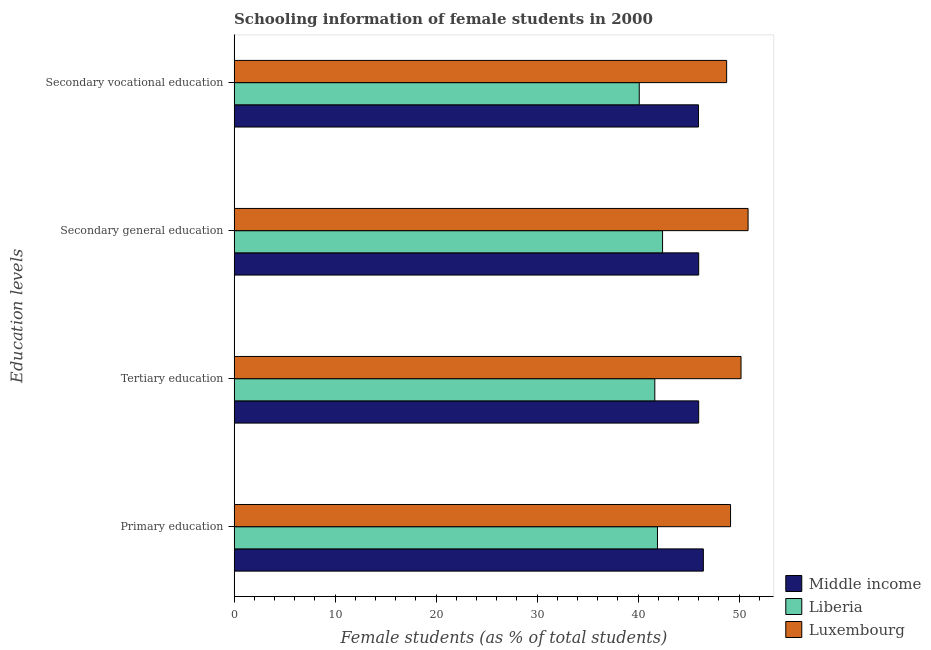How many different coloured bars are there?
Ensure brevity in your answer.  3. How many groups of bars are there?
Keep it short and to the point. 4. Are the number of bars per tick equal to the number of legend labels?
Provide a succinct answer. Yes. Are the number of bars on each tick of the Y-axis equal?
Give a very brief answer. Yes. How many bars are there on the 4th tick from the top?
Make the answer very short. 3. What is the label of the 2nd group of bars from the top?
Offer a very short reply. Secondary general education. What is the percentage of female students in tertiary education in Middle income?
Offer a very short reply. 46. Across all countries, what is the maximum percentage of female students in primary education?
Your answer should be compact. 49.16. Across all countries, what is the minimum percentage of female students in secondary vocational education?
Ensure brevity in your answer.  40.12. In which country was the percentage of female students in primary education maximum?
Provide a short and direct response. Luxembourg. In which country was the percentage of female students in primary education minimum?
Your response must be concise. Liberia. What is the total percentage of female students in primary education in the graph?
Your response must be concise. 137.54. What is the difference between the percentage of female students in secondary vocational education in Luxembourg and that in Middle income?
Give a very brief answer. 2.79. What is the difference between the percentage of female students in primary education in Middle income and the percentage of female students in secondary education in Luxembourg?
Your response must be concise. -4.43. What is the average percentage of female students in primary education per country?
Your answer should be compact. 45.85. What is the difference between the percentage of female students in secondary education and percentage of female students in secondary vocational education in Middle income?
Keep it short and to the point. 0.02. In how many countries, is the percentage of female students in secondary education greater than 38 %?
Make the answer very short. 3. What is the ratio of the percentage of female students in secondary vocational education in Middle income to that in Luxembourg?
Your response must be concise. 0.94. Is the percentage of female students in tertiary education in Middle income less than that in Luxembourg?
Keep it short and to the point. Yes. What is the difference between the highest and the second highest percentage of female students in secondary vocational education?
Ensure brevity in your answer.  2.79. What is the difference between the highest and the lowest percentage of female students in secondary education?
Keep it short and to the point. 8.47. Is the sum of the percentage of female students in tertiary education in Liberia and Luxembourg greater than the maximum percentage of female students in secondary vocational education across all countries?
Your answer should be compact. Yes. Is it the case that in every country, the sum of the percentage of female students in tertiary education and percentage of female students in primary education is greater than the sum of percentage of female students in secondary vocational education and percentage of female students in secondary education?
Your answer should be compact. No. What does the 1st bar from the top in Secondary general education represents?
Offer a terse response. Luxembourg. What does the 3rd bar from the bottom in Secondary vocational education represents?
Offer a very short reply. Luxembourg. Does the graph contain grids?
Your answer should be very brief. No. Where does the legend appear in the graph?
Keep it short and to the point. Bottom right. How are the legend labels stacked?
Keep it short and to the point. Vertical. What is the title of the graph?
Your answer should be very brief. Schooling information of female students in 2000. Does "Seychelles" appear as one of the legend labels in the graph?
Your answer should be compact. No. What is the label or title of the X-axis?
Offer a terse response. Female students (as % of total students). What is the label or title of the Y-axis?
Make the answer very short. Education levels. What is the Female students (as % of total students) of Middle income in Primary education?
Your answer should be compact. 46.46. What is the Female students (as % of total students) of Liberia in Primary education?
Offer a terse response. 41.92. What is the Female students (as % of total students) in Luxembourg in Primary education?
Give a very brief answer. 49.16. What is the Female students (as % of total students) in Middle income in Tertiary education?
Make the answer very short. 46. What is the Female students (as % of total students) of Liberia in Tertiary education?
Make the answer very short. 41.66. What is the Female students (as % of total students) in Luxembourg in Tertiary education?
Your answer should be compact. 50.19. What is the Female students (as % of total students) of Middle income in Secondary general education?
Offer a very short reply. 46. What is the Female students (as % of total students) of Liberia in Secondary general education?
Offer a very short reply. 42.42. What is the Female students (as % of total students) in Luxembourg in Secondary general education?
Ensure brevity in your answer.  50.89. What is the Female students (as % of total students) in Middle income in Secondary vocational education?
Give a very brief answer. 45.98. What is the Female students (as % of total students) in Liberia in Secondary vocational education?
Offer a terse response. 40.12. What is the Female students (as % of total students) in Luxembourg in Secondary vocational education?
Provide a short and direct response. 48.77. Across all Education levels, what is the maximum Female students (as % of total students) of Middle income?
Offer a very short reply. 46.46. Across all Education levels, what is the maximum Female students (as % of total students) of Liberia?
Keep it short and to the point. 42.42. Across all Education levels, what is the maximum Female students (as % of total students) of Luxembourg?
Provide a succinct answer. 50.89. Across all Education levels, what is the minimum Female students (as % of total students) of Middle income?
Offer a terse response. 45.98. Across all Education levels, what is the minimum Female students (as % of total students) in Liberia?
Provide a short and direct response. 40.12. Across all Education levels, what is the minimum Female students (as % of total students) of Luxembourg?
Your answer should be compact. 48.77. What is the total Female students (as % of total students) of Middle income in the graph?
Ensure brevity in your answer.  184.45. What is the total Female students (as % of total students) of Liberia in the graph?
Ensure brevity in your answer.  166.12. What is the total Female students (as % of total students) in Luxembourg in the graph?
Make the answer very short. 199.01. What is the difference between the Female students (as % of total students) in Middle income in Primary education and that in Tertiary education?
Provide a short and direct response. 0.47. What is the difference between the Female students (as % of total students) in Liberia in Primary education and that in Tertiary education?
Provide a succinct answer. 0.26. What is the difference between the Female students (as % of total students) of Luxembourg in Primary education and that in Tertiary education?
Keep it short and to the point. -1.04. What is the difference between the Female students (as % of total students) in Middle income in Primary education and that in Secondary general education?
Your response must be concise. 0.46. What is the difference between the Female students (as % of total students) in Liberia in Primary education and that in Secondary general education?
Provide a succinct answer. -0.51. What is the difference between the Female students (as % of total students) in Luxembourg in Primary education and that in Secondary general education?
Keep it short and to the point. -1.74. What is the difference between the Female students (as % of total students) of Middle income in Primary education and that in Secondary vocational education?
Your answer should be very brief. 0.49. What is the difference between the Female students (as % of total students) in Liberia in Primary education and that in Secondary vocational education?
Your answer should be compact. 1.8. What is the difference between the Female students (as % of total students) in Luxembourg in Primary education and that in Secondary vocational education?
Keep it short and to the point. 0.39. What is the difference between the Female students (as % of total students) of Middle income in Tertiary education and that in Secondary general education?
Keep it short and to the point. -0. What is the difference between the Female students (as % of total students) in Liberia in Tertiary education and that in Secondary general education?
Your answer should be very brief. -0.77. What is the difference between the Female students (as % of total students) in Luxembourg in Tertiary education and that in Secondary general education?
Your response must be concise. -0.7. What is the difference between the Female students (as % of total students) in Middle income in Tertiary education and that in Secondary vocational education?
Your response must be concise. 0.02. What is the difference between the Female students (as % of total students) of Liberia in Tertiary education and that in Secondary vocational education?
Ensure brevity in your answer.  1.54. What is the difference between the Female students (as % of total students) in Luxembourg in Tertiary education and that in Secondary vocational education?
Make the answer very short. 1.42. What is the difference between the Female students (as % of total students) of Middle income in Secondary general education and that in Secondary vocational education?
Keep it short and to the point. 0.02. What is the difference between the Female students (as % of total students) of Liberia in Secondary general education and that in Secondary vocational education?
Your answer should be compact. 2.31. What is the difference between the Female students (as % of total students) in Luxembourg in Secondary general education and that in Secondary vocational education?
Ensure brevity in your answer.  2.12. What is the difference between the Female students (as % of total students) in Middle income in Primary education and the Female students (as % of total students) in Liberia in Tertiary education?
Provide a succinct answer. 4.81. What is the difference between the Female students (as % of total students) in Middle income in Primary education and the Female students (as % of total students) in Luxembourg in Tertiary education?
Make the answer very short. -3.73. What is the difference between the Female students (as % of total students) in Liberia in Primary education and the Female students (as % of total students) in Luxembourg in Tertiary education?
Offer a terse response. -8.27. What is the difference between the Female students (as % of total students) of Middle income in Primary education and the Female students (as % of total students) of Liberia in Secondary general education?
Give a very brief answer. 4.04. What is the difference between the Female students (as % of total students) in Middle income in Primary education and the Female students (as % of total students) in Luxembourg in Secondary general education?
Keep it short and to the point. -4.43. What is the difference between the Female students (as % of total students) in Liberia in Primary education and the Female students (as % of total students) in Luxembourg in Secondary general education?
Give a very brief answer. -8.97. What is the difference between the Female students (as % of total students) of Middle income in Primary education and the Female students (as % of total students) of Liberia in Secondary vocational education?
Ensure brevity in your answer.  6.35. What is the difference between the Female students (as % of total students) of Middle income in Primary education and the Female students (as % of total students) of Luxembourg in Secondary vocational education?
Keep it short and to the point. -2.31. What is the difference between the Female students (as % of total students) of Liberia in Primary education and the Female students (as % of total students) of Luxembourg in Secondary vocational education?
Provide a succinct answer. -6.85. What is the difference between the Female students (as % of total students) in Middle income in Tertiary education and the Female students (as % of total students) in Liberia in Secondary general education?
Your answer should be compact. 3.57. What is the difference between the Female students (as % of total students) in Middle income in Tertiary education and the Female students (as % of total students) in Luxembourg in Secondary general education?
Keep it short and to the point. -4.89. What is the difference between the Female students (as % of total students) in Liberia in Tertiary education and the Female students (as % of total students) in Luxembourg in Secondary general education?
Your response must be concise. -9.23. What is the difference between the Female students (as % of total students) of Middle income in Tertiary education and the Female students (as % of total students) of Liberia in Secondary vocational education?
Offer a terse response. 5.88. What is the difference between the Female students (as % of total students) in Middle income in Tertiary education and the Female students (as % of total students) in Luxembourg in Secondary vocational education?
Your answer should be very brief. -2.77. What is the difference between the Female students (as % of total students) of Liberia in Tertiary education and the Female students (as % of total students) of Luxembourg in Secondary vocational education?
Ensure brevity in your answer.  -7.11. What is the difference between the Female students (as % of total students) in Middle income in Secondary general education and the Female students (as % of total students) in Liberia in Secondary vocational education?
Provide a succinct answer. 5.89. What is the difference between the Female students (as % of total students) in Middle income in Secondary general education and the Female students (as % of total students) in Luxembourg in Secondary vocational education?
Your answer should be compact. -2.77. What is the difference between the Female students (as % of total students) in Liberia in Secondary general education and the Female students (as % of total students) in Luxembourg in Secondary vocational education?
Your answer should be very brief. -6.34. What is the average Female students (as % of total students) of Middle income per Education levels?
Your answer should be compact. 46.11. What is the average Female students (as % of total students) of Liberia per Education levels?
Offer a very short reply. 41.53. What is the average Female students (as % of total students) of Luxembourg per Education levels?
Give a very brief answer. 49.75. What is the difference between the Female students (as % of total students) in Middle income and Female students (as % of total students) in Liberia in Primary education?
Offer a very short reply. 4.55. What is the difference between the Female students (as % of total students) in Middle income and Female students (as % of total students) in Luxembourg in Primary education?
Your response must be concise. -2.69. What is the difference between the Female students (as % of total students) in Liberia and Female students (as % of total students) in Luxembourg in Primary education?
Your answer should be very brief. -7.24. What is the difference between the Female students (as % of total students) in Middle income and Female students (as % of total students) in Liberia in Tertiary education?
Ensure brevity in your answer.  4.34. What is the difference between the Female students (as % of total students) in Middle income and Female students (as % of total students) in Luxembourg in Tertiary education?
Your response must be concise. -4.19. What is the difference between the Female students (as % of total students) in Liberia and Female students (as % of total students) in Luxembourg in Tertiary education?
Offer a very short reply. -8.54. What is the difference between the Female students (as % of total students) of Middle income and Female students (as % of total students) of Liberia in Secondary general education?
Offer a terse response. 3.58. What is the difference between the Female students (as % of total students) in Middle income and Female students (as % of total students) in Luxembourg in Secondary general education?
Offer a terse response. -4.89. What is the difference between the Female students (as % of total students) in Liberia and Female students (as % of total students) in Luxembourg in Secondary general education?
Ensure brevity in your answer.  -8.47. What is the difference between the Female students (as % of total students) of Middle income and Female students (as % of total students) of Liberia in Secondary vocational education?
Offer a very short reply. 5.86. What is the difference between the Female students (as % of total students) of Middle income and Female students (as % of total students) of Luxembourg in Secondary vocational education?
Your response must be concise. -2.79. What is the difference between the Female students (as % of total students) in Liberia and Female students (as % of total students) in Luxembourg in Secondary vocational education?
Your answer should be very brief. -8.65. What is the ratio of the Female students (as % of total students) in Middle income in Primary education to that in Tertiary education?
Your response must be concise. 1.01. What is the ratio of the Female students (as % of total students) in Liberia in Primary education to that in Tertiary education?
Ensure brevity in your answer.  1.01. What is the ratio of the Female students (as % of total students) in Luxembourg in Primary education to that in Tertiary education?
Offer a very short reply. 0.98. What is the ratio of the Female students (as % of total students) in Middle income in Primary education to that in Secondary general education?
Your response must be concise. 1.01. What is the ratio of the Female students (as % of total students) in Liberia in Primary education to that in Secondary general education?
Provide a succinct answer. 0.99. What is the ratio of the Female students (as % of total students) of Luxembourg in Primary education to that in Secondary general education?
Offer a terse response. 0.97. What is the ratio of the Female students (as % of total students) of Middle income in Primary education to that in Secondary vocational education?
Your answer should be compact. 1.01. What is the ratio of the Female students (as % of total students) of Liberia in Primary education to that in Secondary vocational education?
Provide a short and direct response. 1.04. What is the ratio of the Female students (as % of total students) in Luxembourg in Primary education to that in Secondary vocational education?
Provide a succinct answer. 1.01. What is the ratio of the Female students (as % of total students) of Middle income in Tertiary education to that in Secondary general education?
Your answer should be very brief. 1. What is the ratio of the Female students (as % of total students) of Liberia in Tertiary education to that in Secondary general education?
Your response must be concise. 0.98. What is the ratio of the Female students (as % of total students) of Luxembourg in Tertiary education to that in Secondary general education?
Provide a succinct answer. 0.99. What is the ratio of the Female students (as % of total students) in Middle income in Tertiary education to that in Secondary vocational education?
Ensure brevity in your answer.  1. What is the ratio of the Female students (as % of total students) in Liberia in Tertiary education to that in Secondary vocational education?
Provide a short and direct response. 1.04. What is the ratio of the Female students (as % of total students) in Luxembourg in Tertiary education to that in Secondary vocational education?
Make the answer very short. 1.03. What is the ratio of the Female students (as % of total students) of Middle income in Secondary general education to that in Secondary vocational education?
Your answer should be compact. 1. What is the ratio of the Female students (as % of total students) of Liberia in Secondary general education to that in Secondary vocational education?
Provide a short and direct response. 1.06. What is the ratio of the Female students (as % of total students) of Luxembourg in Secondary general education to that in Secondary vocational education?
Your answer should be compact. 1.04. What is the difference between the highest and the second highest Female students (as % of total students) in Middle income?
Your response must be concise. 0.46. What is the difference between the highest and the second highest Female students (as % of total students) in Liberia?
Your response must be concise. 0.51. What is the difference between the highest and the second highest Female students (as % of total students) of Luxembourg?
Your response must be concise. 0.7. What is the difference between the highest and the lowest Female students (as % of total students) of Middle income?
Give a very brief answer. 0.49. What is the difference between the highest and the lowest Female students (as % of total students) of Liberia?
Make the answer very short. 2.31. What is the difference between the highest and the lowest Female students (as % of total students) in Luxembourg?
Keep it short and to the point. 2.12. 